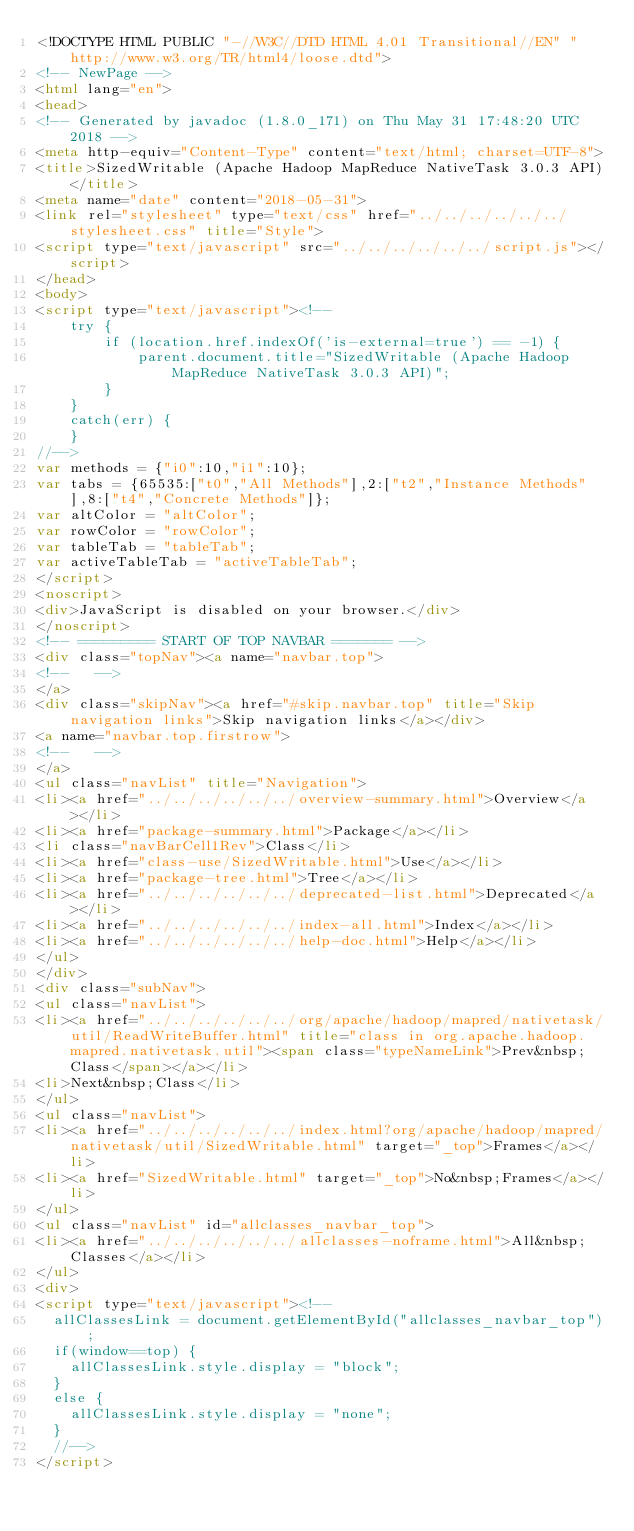<code> <loc_0><loc_0><loc_500><loc_500><_HTML_><!DOCTYPE HTML PUBLIC "-//W3C//DTD HTML 4.01 Transitional//EN" "http://www.w3.org/TR/html4/loose.dtd">
<!-- NewPage -->
<html lang="en">
<head>
<!-- Generated by javadoc (1.8.0_171) on Thu May 31 17:48:20 UTC 2018 -->
<meta http-equiv="Content-Type" content="text/html; charset=UTF-8">
<title>SizedWritable (Apache Hadoop MapReduce NativeTask 3.0.3 API)</title>
<meta name="date" content="2018-05-31">
<link rel="stylesheet" type="text/css" href="../../../../../../stylesheet.css" title="Style">
<script type="text/javascript" src="../../../../../../script.js"></script>
</head>
<body>
<script type="text/javascript"><!--
    try {
        if (location.href.indexOf('is-external=true') == -1) {
            parent.document.title="SizedWritable (Apache Hadoop MapReduce NativeTask 3.0.3 API)";
        }
    }
    catch(err) {
    }
//-->
var methods = {"i0":10,"i1":10};
var tabs = {65535:["t0","All Methods"],2:["t2","Instance Methods"],8:["t4","Concrete Methods"]};
var altColor = "altColor";
var rowColor = "rowColor";
var tableTab = "tableTab";
var activeTableTab = "activeTableTab";
</script>
<noscript>
<div>JavaScript is disabled on your browser.</div>
</noscript>
<!-- ========= START OF TOP NAVBAR ======= -->
<div class="topNav"><a name="navbar.top">
<!--   -->
</a>
<div class="skipNav"><a href="#skip.navbar.top" title="Skip navigation links">Skip navigation links</a></div>
<a name="navbar.top.firstrow">
<!--   -->
</a>
<ul class="navList" title="Navigation">
<li><a href="../../../../../../overview-summary.html">Overview</a></li>
<li><a href="package-summary.html">Package</a></li>
<li class="navBarCell1Rev">Class</li>
<li><a href="class-use/SizedWritable.html">Use</a></li>
<li><a href="package-tree.html">Tree</a></li>
<li><a href="../../../../../../deprecated-list.html">Deprecated</a></li>
<li><a href="../../../../../../index-all.html">Index</a></li>
<li><a href="../../../../../../help-doc.html">Help</a></li>
</ul>
</div>
<div class="subNav">
<ul class="navList">
<li><a href="../../../../../../org/apache/hadoop/mapred/nativetask/util/ReadWriteBuffer.html" title="class in org.apache.hadoop.mapred.nativetask.util"><span class="typeNameLink">Prev&nbsp;Class</span></a></li>
<li>Next&nbsp;Class</li>
</ul>
<ul class="navList">
<li><a href="../../../../../../index.html?org/apache/hadoop/mapred/nativetask/util/SizedWritable.html" target="_top">Frames</a></li>
<li><a href="SizedWritable.html" target="_top">No&nbsp;Frames</a></li>
</ul>
<ul class="navList" id="allclasses_navbar_top">
<li><a href="../../../../../../allclasses-noframe.html">All&nbsp;Classes</a></li>
</ul>
<div>
<script type="text/javascript"><!--
  allClassesLink = document.getElementById("allclasses_navbar_top");
  if(window==top) {
    allClassesLink.style.display = "block";
  }
  else {
    allClassesLink.style.display = "none";
  }
  //-->
</script></code> 